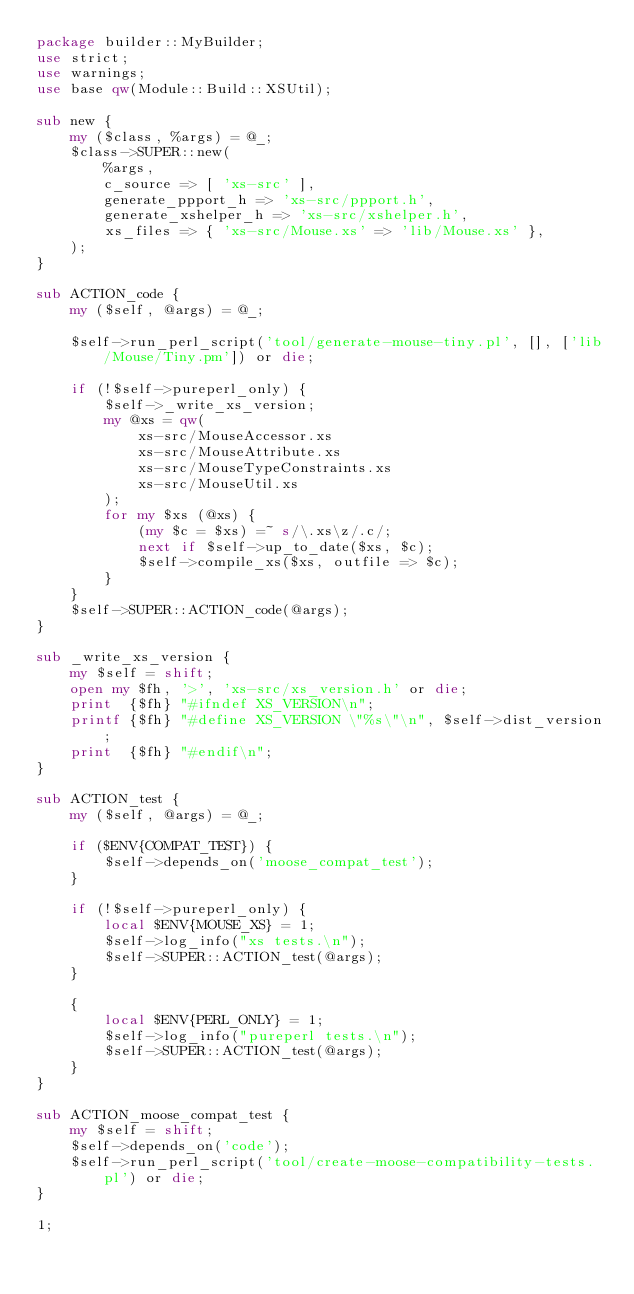<code> <loc_0><loc_0><loc_500><loc_500><_Perl_>package builder::MyBuilder;
use strict;
use warnings;
use base qw(Module::Build::XSUtil);

sub new {
    my ($class, %args) = @_;
    $class->SUPER::new(
        %args,
        c_source => [ 'xs-src' ],
        generate_ppport_h => 'xs-src/ppport.h',
        generate_xshelper_h => 'xs-src/xshelper.h',
        xs_files => { 'xs-src/Mouse.xs' => 'lib/Mouse.xs' },
    );
}

sub ACTION_code {
    my ($self, @args) = @_;

    $self->run_perl_script('tool/generate-mouse-tiny.pl', [], ['lib/Mouse/Tiny.pm']) or die;

    if (!$self->pureperl_only) {
        $self->_write_xs_version;
        my @xs = qw(
            xs-src/MouseAccessor.xs
            xs-src/MouseAttribute.xs
            xs-src/MouseTypeConstraints.xs
            xs-src/MouseUtil.xs
        );
        for my $xs (@xs) {
            (my $c = $xs) =~ s/\.xs\z/.c/;
            next if $self->up_to_date($xs, $c);
            $self->compile_xs($xs, outfile => $c);
        }
    }
    $self->SUPER::ACTION_code(@args);
}

sub _write_xs_version {
    my $self = shift;
    open my $fh, '>', 'xs-src/xs_version.h' or die;
    print  {$fh} "#ifndef XS_VERSION\n";
    printf {$fh} "#define XS_VERSION \"%s\"\n", $self->dist_version;
    print  {$fh} "#endif\n";
}

sub ACTION_test {
    my ($self, @args) = @_;

    if ($ENV{COMPAT_TEST}) {
        $self->depends_on('moose_compat_test');
    }

    if (!$self->pureperl_only) {
        local $ENV{MOUSE_XS} = 1;
        $self->log_info("xs tests.\n");
        $self->SUPER::ACTION_test(@args);
    }

    {
        local $ENV{PERL_ONLY} = 1;
        $self->log_info("pureperl tests.\n");
        $self->SUPER::ACTION_test(@args);
    }
}

sub ACTION_moose_compat_test {
    my $self = shift;
    $self->depends_on('code');
    $self->run_perl_script('tool/create-moose-compatibility-tests.pl') or die;
}

1;
</code> 